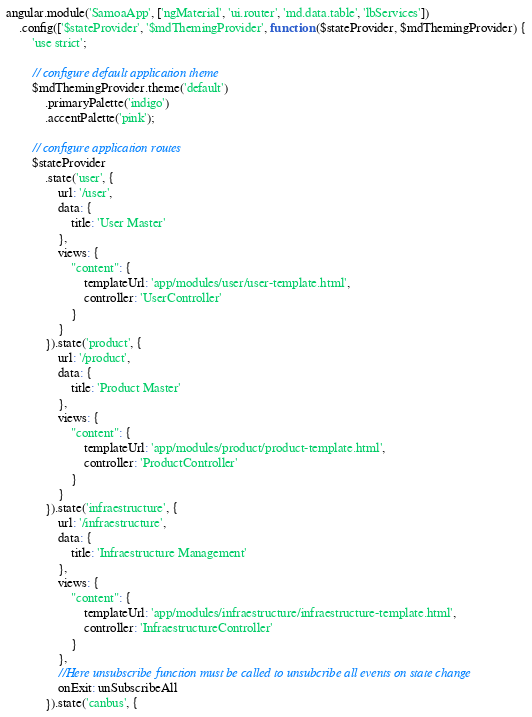Convert code to text. <code><loc_0><loc_0><loc_500><loc_500><_JavaScript_>angular.module('SamoaApp', ['ngMaterial', 'ui.router', 'md.data.table', 'lbServices'])
    .config(['$stateProvider', '$mdThemingProvider', function ($stateProvider, $mdThemingProvider) {
        'use strict';

        // configure default application theme
        $mdThemingProvider.theme('default')
            .primaryPalette('indigo')
            .accentPalette('pink');

        // configure application routes
        $stateProvider
            .state('user', {
                url: '/user',
                data: {
                    title: 'User Master'
                },
                views: {
                    "content": {
                        templateUrl: 'app/modules/user/user-template.html',
                        controller: 'UserController'
                    }
                }
            }).state('product', {
                url: '/product',
                data: {
                    title: 'Product Master'
                },
                views: {
                    "content": {
                        templateUrl: 'app/modules/product/product-template.html',
                        controller: 'ProductController'
                    }
                }
            }).state('infraestructure', {
                url: '/infraestructure',
                data: {
                    title: 'Infraestructure Management'
                },
                views: {
                    "content": {
                        templateUrl: 'app/modules/infraestructure/infraestructure-template.html',
                        controller: 'InfraestructureController'
                    }
                },
                //Here unsubscribe function must be called to unsubcribe all events on state change
                onExit: unSubscribeAll
            }).state('canbus', {</code> 